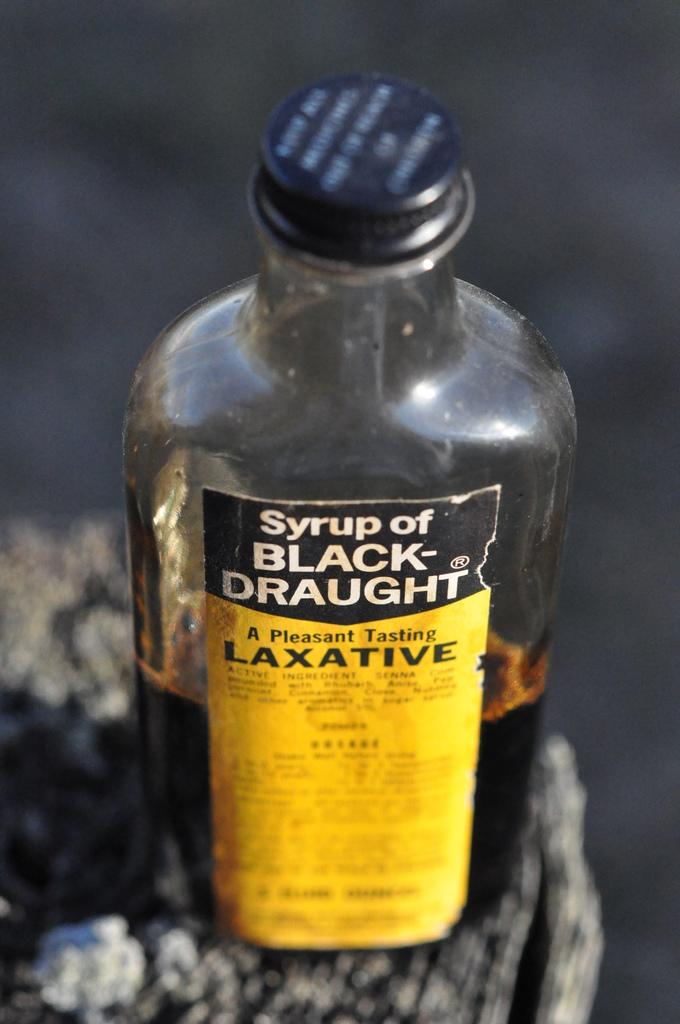What object is present in the image? There is a bottle in the image. What can be seen on the cap of the bottle? The cap of the bottle is black. What is written on the bottle? The words "Syrup of BLACK-Draught" are written on the bottle. How many insects are crawling on the bottle in the image? There are no insects present on the bottle in the image. Can you describe the type of fly that is buzzing around the bottle in the image? There is no fly present around the bottle in the image. 